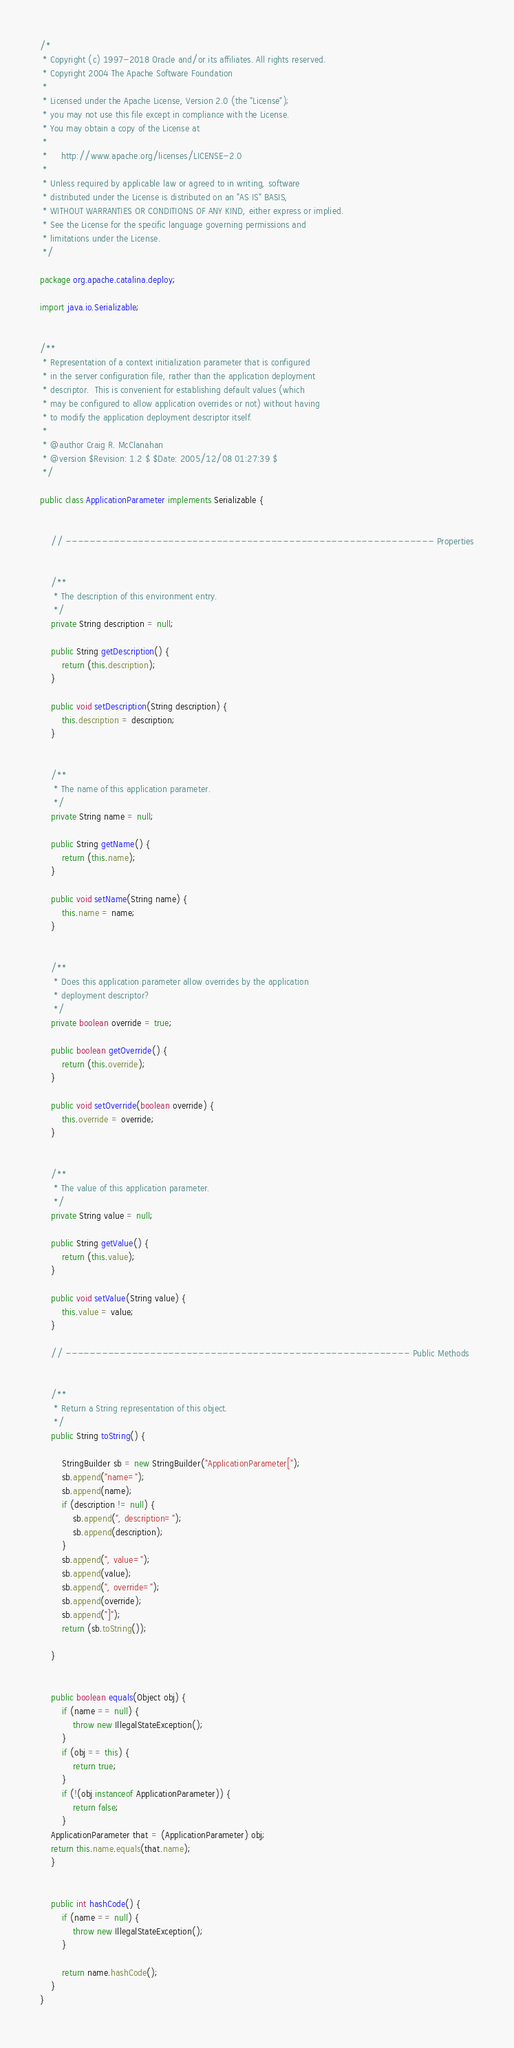Convert code to text. <code><loc_0><loc_0><loc_500><loc_500><_Java_>/*
 * Copyright (c) 1997-2018 Oracle and/or its affiliates. All rights reserved.
 * Copyright 2004 The Apache Software Foundation
 *
 * Licensed under the Apache License, Version 2.0 (the "License");
 * you may not use this file except in compliance with the License.
 * You may obtain a copy of the License at
 *
 *     http://www.apache.org/licenses/LICENSE-2.0
 *
 * Unless required by applicable law or agreed to in writing, software
 * distributed under the License is distributed on an "AS IS" BASIS,
 * WITHOUT WARRANTIES OR CONDITIONS OF ANY KIND, either express or implied.
 * See the License for the specific language governing permissions and
 * limitations under the License.
 */

package org.apache.catalina.deploy;

import java.io.Serializable;


/**
 * Representation of a context initialization parameter that is configured
 * in the server configuration file, rather than the application deployment
 * descriptor.  This is convenient for establishing default values (which
 * may be configured to allow application overrides or not) without having
 * to modify the application deployment descriptor itself.
 *
 * @author Craig R. McClanahan
 * @version $Revision: 1.2 $ $Date: 2005/12/08 01:27:39 $
 */

public class ApplicationParameter implements Serializable {


    // ------------------------------------------------------------- Properties


    /**
     * The description of this environment entry.
     */
    private String description = null;

    public String getDescription() {
        return (this.description);
    }

    public void setDescription(String description) {
        this.description = description;
    }


    /**
     * The name of this application parameter.
     */
    private String name = null;

    public String getName() {
        return (this.name);
    }

    public void setName(String name) {
        this.name = name;
    }


    /**
     * Does this application parameter allow overrides by the application
     * deployment descriptor?
     */
    private boolean override = true;

    public boolean getOverride() {
        return (this.override);
    }

    public void setOverride(boolean override) {
        this.override = override;
    }


    /**
     * The value of this application parameter.
     */
    private String value = null;

    public String getValue() {
        return (this.value);
    }

    public void setValue(String value) {
        this.value = value;
    }

    // --------------------------------------------------------- Public Methods


    /**
     * Return a String representation of this object.
     */
    public String toString() {

        StringBuilder sb = new StringBuilder("ApplicationParameter[");
        sb.append("name=");
        sb.append(name);
        if (description != null) {
            sb.append(", description=");
            sb.append(description);
        }
        sb.append(", value=");
        sb.append(value);
        sb.append(", override=");
        sb.append(override);
        sb.append("]");
        return (sb.toString());

    }


    public boolean equals(Object obj) {
        if (name == null) {
            throw new IllegalStateException();
        }
        if (obj == this) {
            return true;
        }
        if (!(obj instanceof ApplicationParameter)) {
            return false;
        }
	ApplicationParameter that = (ApplicationParameter) obj;
	return this.name.equals(that.name);
    }


    public int hashCode() {
        if (name == null) {
            throw new IllegalStateException();
        }
       
        return name.hashCode();
    }
}
</code> 